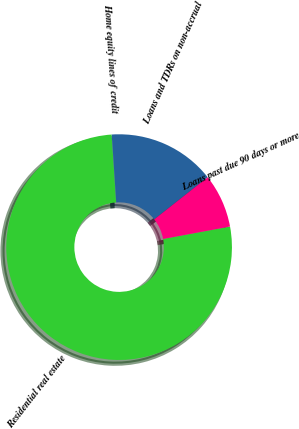<chart> <loc_0><loc_0><loc_500><loc_500><pie_chart><fcel>Residential real estate<fcel>Home equity lines of credit<fcel>Loans and TDRs on non-accrual<fcel>Loans past due 90 days or more<nl><fcel>76.87%<fcel>0.03%<fcel>15.4%<fcel>7.71%<nl></chart> 